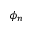Convert formula to latex. <formula><loc_0><loc_0><loc_500><loc_500>\phi _ { n }</formula> 